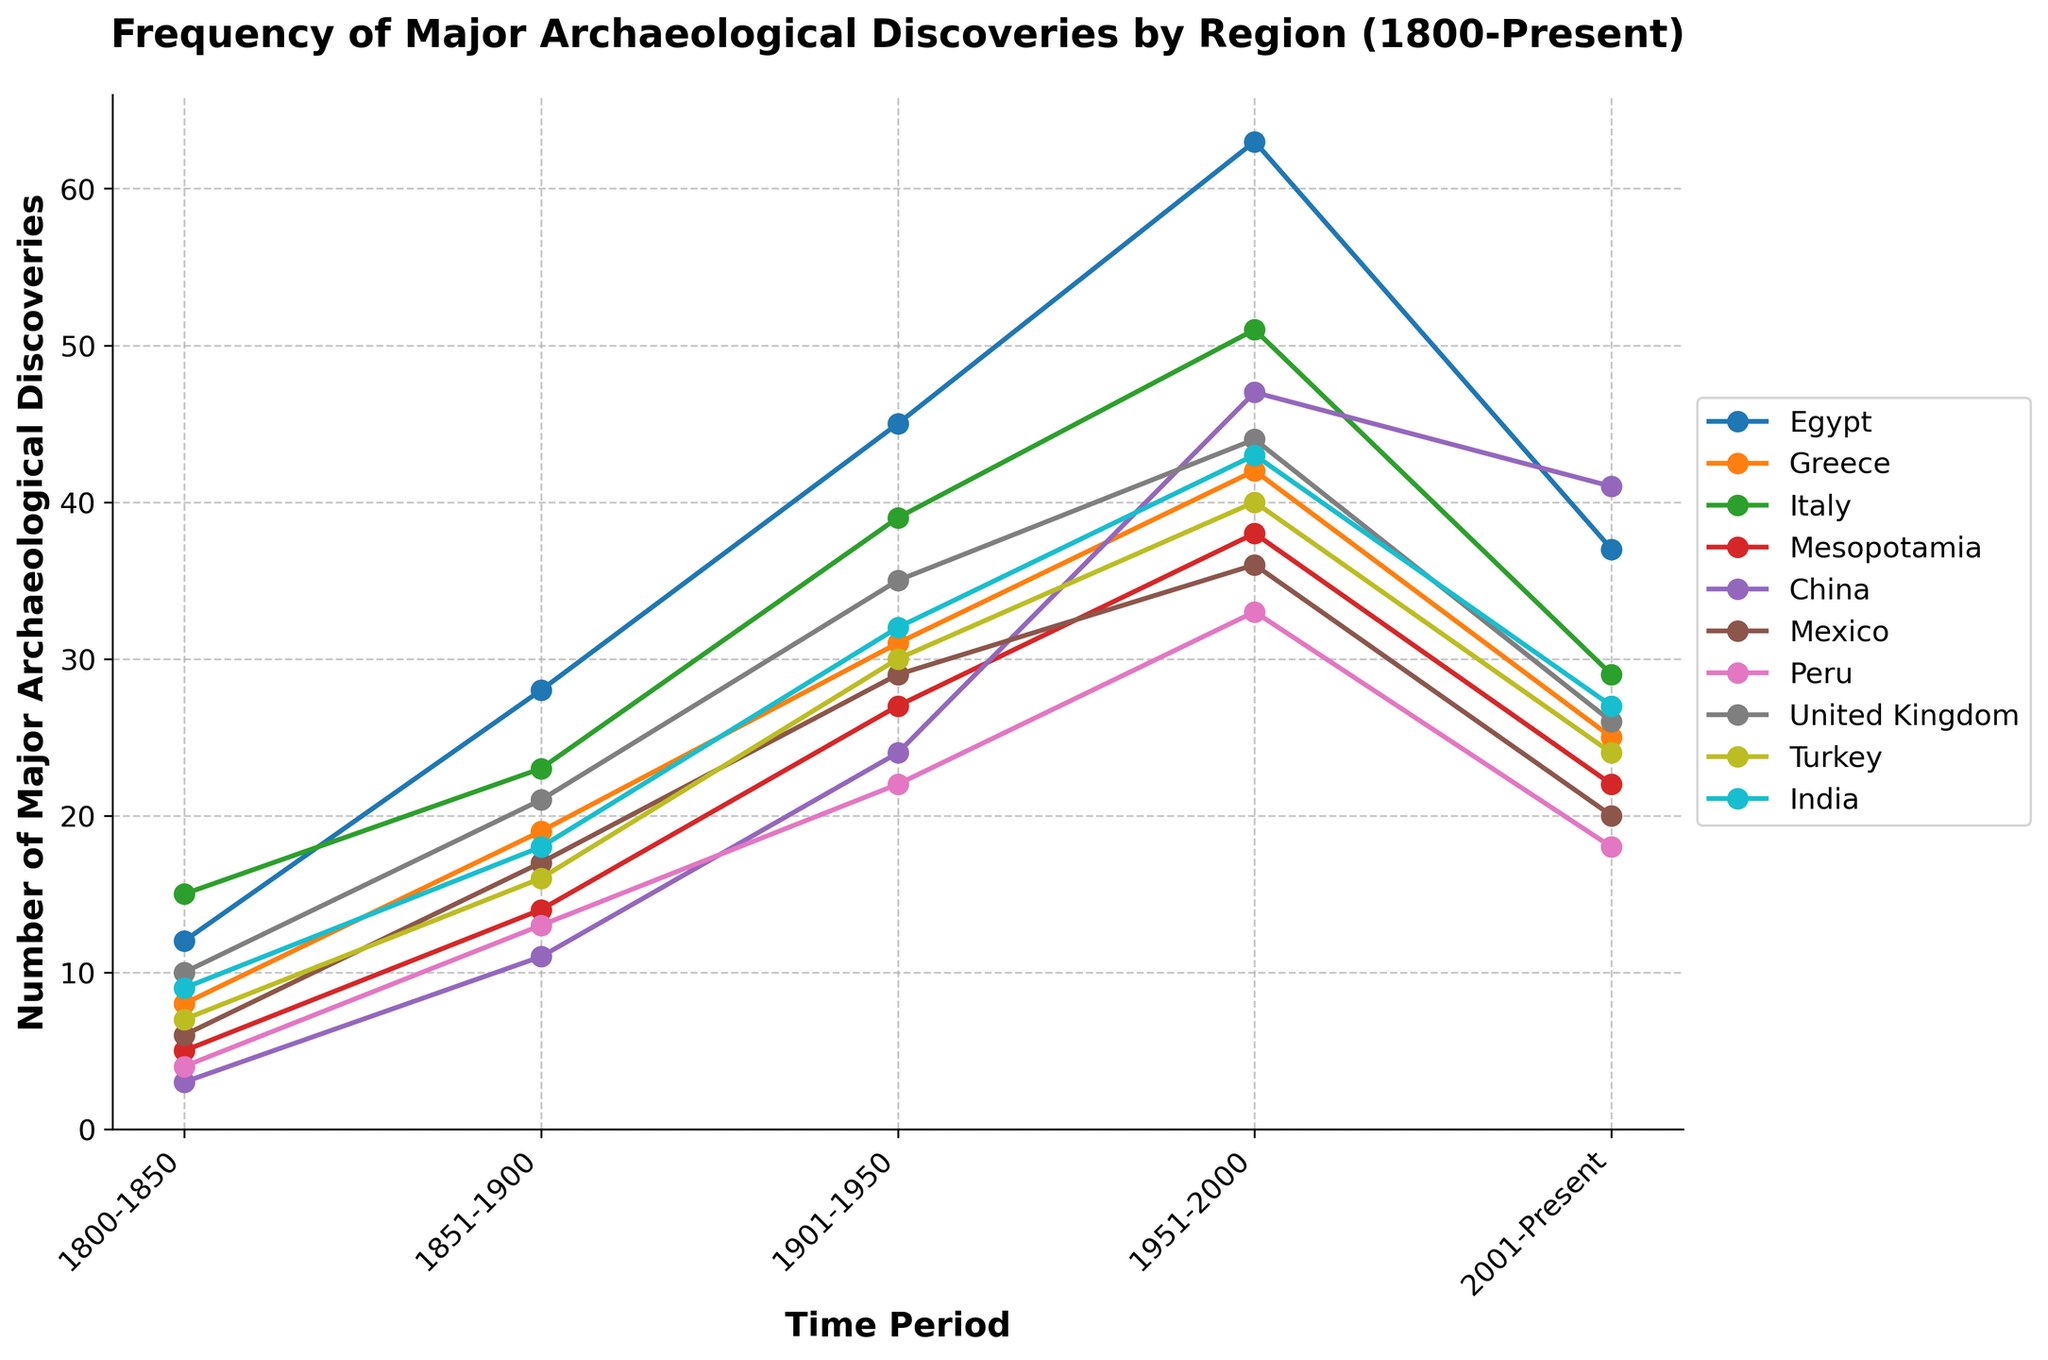Which region experienced the most archaeological discoveries between 2001-Present? Look at the most recent data points (2001-Present) for each region and identify which one has the highest value. Egypt has 37, Greece has 25, Italy has 29, Mesopotamia has 22, China has 41, Mexico has 20, Peru has 18, United Kingdom has 26, Turkey has 24, and India has 27—China has the highest value.
Answer: China How did the frequency of discoveries in Mesopotamia change from 1800-1850 to 1851-1900? Compare the number of discoveries in Mesopotamia for the time periods 1800-1850 (5) and 1851-1900 (14). Calculate the difference: 14 - 5 = 9.
Answer: Increased by 9 Which region had fewer discoveries in 2001-Present compared to 1951-2000? Look at the data for the periods 1951-2000 and 2001-Present for each region and identify which ones decreased. Egypt (63 to 37), Greece (42 to 25), Italy (51 to 29), Mesopotamia (38 to 22), Mexico (36 to 20), Peru (33 to 18), United Kingdom (44 to 26), Turkey (40 to 24), and India (43 to 27) all had fewer discoveries. China increased, so ignore it.
Answer: Egypt, Greece, Italy, Mesopotamia, Mexico, Peru, United Kingdom, Turkey, India What is the average number of discoveries for Greece across all time periods? Sum all the values for Greece (8 + 19 + 31 + 42 + 25) = 125, and then divide by the number of periods (5). 125 / 5 = 25.
Answer: 25 In which time period did Peru achieve the highest number of discoveries? Review the data points for Peru across all periods: 1800-1850 (4), 1851-1900 (13), 1901-1950 (22), 1951-2000 (33), 2001-Present (18). Identify the highest value, which is 33 in the period 1951-2000.
Answer: 1951-2000 Which region had the least discoveries between 1800-1850? Compare the data for 1800-1850 for each region and find the lowest value. Egypt (12), Greece (8), Italy (15), Mesopotamia (5), China (3), Mexico (6), Peru (4), United Kingdom (10), Turkey (7), India (9). China has the lowest value.
Answer: China How does the trend in Italy's discoveries from 1800 to present compare to that of Turkey? Compare the plotted lines for Italy and Turkey. Both lines generally increase from 1800-1950, then show a peak during 1951-2000, and decrease in 2001-Present. Specifically, Italy goes from 15 to 23 to 39 to 51 to 29, while Turkey goes from 7 to 16 to 30 to 40 to 24. The trends are similar with a peak during 1951-2000 followed by a decline.
Answer: Similar trends with a peak during 1951-2000 What is the combined total of discoveries in Egypt and Greece during 1851-1900? Add the values for Egypt (28) and Greece (19) during this period: 28 + 19 = 47.
Answer: 47 By how much did the discoveries in China increase from 1800-1850 to 1951-2000? Calculate the difference between the values in these periods for China: 47 (1951-2000) - 3 (1800-1850) = 44.
Answer: 44 Which region had a constant increase in discoveries across all time periods? Look at the trends for each region. Only China shows a consistent increase across all periods: 1800-1850 (3), 1851-1900 (11), 1901-1950 (24), 1951-2000 (47), 2001-Present (41).
Answer: None 